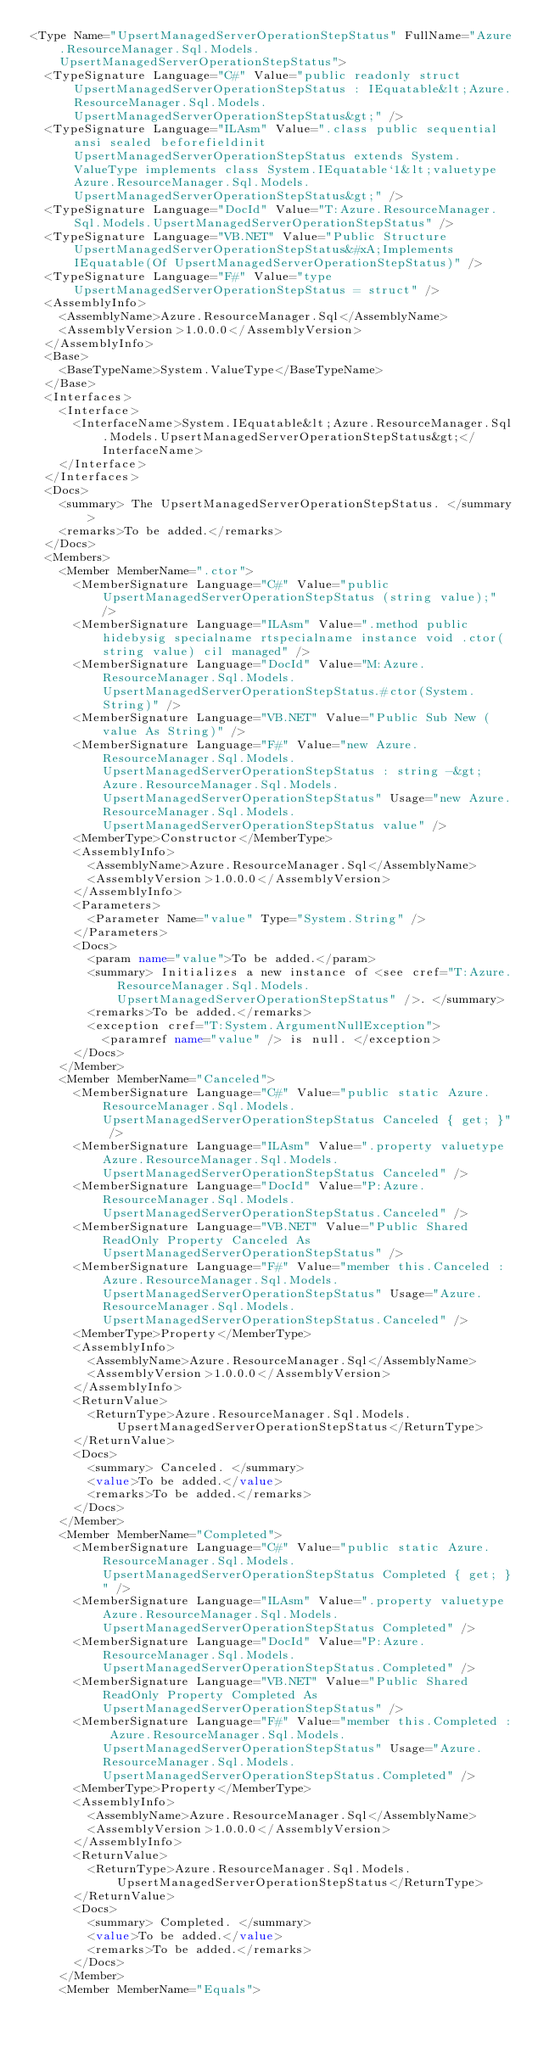Convert code to text. <code><loc_0><loc_0><loc_500><loc_500><_XML_><Type Name="UpsertManagedServerOperationStepStatus" FullName="Azure.ResourceManager.Sql.Models.UpsertManagedServerOperationStepStatus">
  <TypeSignature Language="C#" Value="public readonly struct UpsertManagedServerOperationStepStatus : IEquatable&lt;Azure.ResourceManager.Sql.Models.UpsertManagedServerOperationStepStatus&gt;" />
  <TypeSignature Language="ILAsm" Value=".class public sequential ansi sealed beforefieldinit UpsertManagedServerOperationStepStatus extends System.ValueType implements class System.IEquatable`1&lt;valuetype Azure.ResourceManager.Sql.Models.UpsertManagedServerOperationStepStatus&gt;" />
  <TypeSignature Language="DocId" Value="T:Azure.ResourceManager.Sql.Models.UpsertManagedServerOperationStepStatus" />
  <TypeSignature Language="VB.NET" Value="Public Structure UpsertManagedServerOperationStepStatus&#xA;Implements IEquatable(Of UpsertManagedServerOperationStepStatus)" />
  <TypeSignature Language="F#" Value="type UpsertManagedServerOperationStepStatus = struct" />
  <AssemblyInfo>
    <AssemblyName>Azure.ResourceManager.Sql</AssemblyName>
    <AssemblyVersion>1.0.0.0</AssemblyVersion>
  </AssemblyInfo>
  <Base>
    <BaseTypeName>System.ValueType</BaseTypeName>
  </Base>
  <Interfaces>
    <Interface>
      <InterfaceName>System.IEquatable&lt;Azure.ResourceManager.Sql.Models.UpsertManagedServerOperationStepStatus&gt;</InterfaceName>
    </Interface>
  </Interfaces>
  <Docs>
    <summary> The UpsertManagedServerOperationStepStatus. </summary>
    <remarks>To be added.</remarks>
  </Docs>
  <Members>
    <Member MemberName=".ctor">
      <MemberSignature Language="C#" Value="public UpsertManagedServerOperationStepStatus (string value);" />
      <MemberSignature Language="ILAsm" Value=".method public hidebysig specialname rtspecialname instance void .ctor(string value) cil managed" />
      <MemberSignature Language="DocId" Value="M:Azure.ResourceManager.Sql.Models.UpsertManagedServerOperationStepStatus.#ctor(System.String)" />
      <MemberSignature Language="VB.NET" Value="Public Sub New (value As String)" />
      <MemberSignature Language="F#" Value="new Azure.ResourceManager.Sql.Models.UpsertManagedServerOperationStepStatus : string -&gt; Azure.ResourceManager.Sql.Models.UpsertManagedServerOperationStepStatus" Usage="new Azure.ResourceManager.Sql.Models.UpsertManagedServerOperationStepStatus value" />
      <MemberType>Constructor</MemberType>
      <AssemblyInfo>
        <AssemblyName>Azure.ResourceManager.Sql</AssemblyName>
        <AssemblyVersion>1.0.0.0</AssemblyVersion>
      </AssemblyInfo>
      <Parameters>
        <Parameter Name="value" Type="System.String" />
      </Parameters>
      <Docs>
        <param name="value">To be added.</param>
        <summary> Initializes a new instance of <see cref="T:Azure.ResourceManager.Sql.Models.UpsertManagedServerOperationStepStatus" />. </summary>
        <remarks>To be added.</remarks>
        <exception cref="T:System.ArgumentNullException">
          <paramref name="value" /> is null. </exception>
      </Docs>
    </Member>
    <Member MemberName="Canceled">
      <MemberSignature Language="C#" Value="public static Azure.ResourceManager.Sql.Models.UpsertManagedServerOperationStepStatus Canceled { get; }" />
      <MemberSignature Language="ILAsm" Value=".property valuetype Azure.ResourceManager.Sql.Models.UpsertManagedServerOperationStepStatus Canceled" />
      <MemberSignature Language="DocId" Value="P:Azure.ResourceManager.Sql.Models.UpsertManagedServerOperationStepStatus.Canceled" />
      <MemberSignature Language="VB.NET" Value="Public Shared ReadOnly Property Canceled As UpsertManagedServerOperationStepStatus" />
      <MemberSignature Language="F#" Value="member this.Canceled : Azure.ResourceManager.Sql.Models.UpsertManagedServerOperationStepStatus" Usage="Azure.ResourceManager.Sql.Models.UpsertManagedServerOperationStepStatus.Canceled" />
      <MemberType>Property</MemberType>
      <AssemblyInfo>
        <AssemblyName>Azure.ResourceManager.Sql</AssemblyName>
        <AssemblyVersion>1.0.0.0</AssemblyVersion>
      </AssemblyInfo>
      <ReturnValue>
        <ReturnType>Azure.ResourceManager.Sql.Models.UpsertManagedServerOperationStepStatus</ReturnType>
      </ReturnValue>
      <Docs>
        <summary> Canceled. </summary>
        <value>To be added.</value>
        <remarks>To be added.</remarks>
      </Docs>
    </Member>
    <Member MemberName="Completed">
      <MemberSignature Language="C#" Value="public static Azure.ResourceManager.Sql.Models.UpsertManagedServerOperationStepStatus Completed { get; }" />
      <MemberSignature Language="ILAsm" Value=".property valuetype Azure.ResourceManager.Sql.Models.UpsertManagedServerOperationStepStatus Completed" />
      <MemberSignature Language="DocId" Value="P:Azure.ResourceManager.Sql.Models.UpsertManagedServerOperationStepStatus.Completed" />
      <MemberSignature Language="VB.NET" Value="Public Shared ReadOnly Property Completed As UpsertManagedServerOperationStepStatus" />
      <MemberSignature Language="F#" Value="member this.Completed : Azure.ResourceManager.Sql.Models.UpsertManagedServerOperationStepStatus" Usage="Azure.ResourceManager.Sql.Models.UpsertManagedServerOperationStepStatus.Completed" />
      <MemberType>Property</MemberType>
      <AssemblyInfo>
        <AssemblyName>Azure.ResourceManager.Sql</AssemblyName>
        <AssemblyVersion>1.0.0.0</AssemblyVersion>
      </AssemblyInfo>
      <ReturnValue>
        <ReturnType>Azure.ResourceManager.Sql.Models.UpsertManagedServerOperationStepStatus</ReturnType>
      </ReturnValue>
      <Docs>
        <summary> Completed. </summary>
        <value>To be added.</value>
        <remarks>To be added.</remarks>
      </Docs>
    </Member>
    <Member MemberName="Equals"></code> 